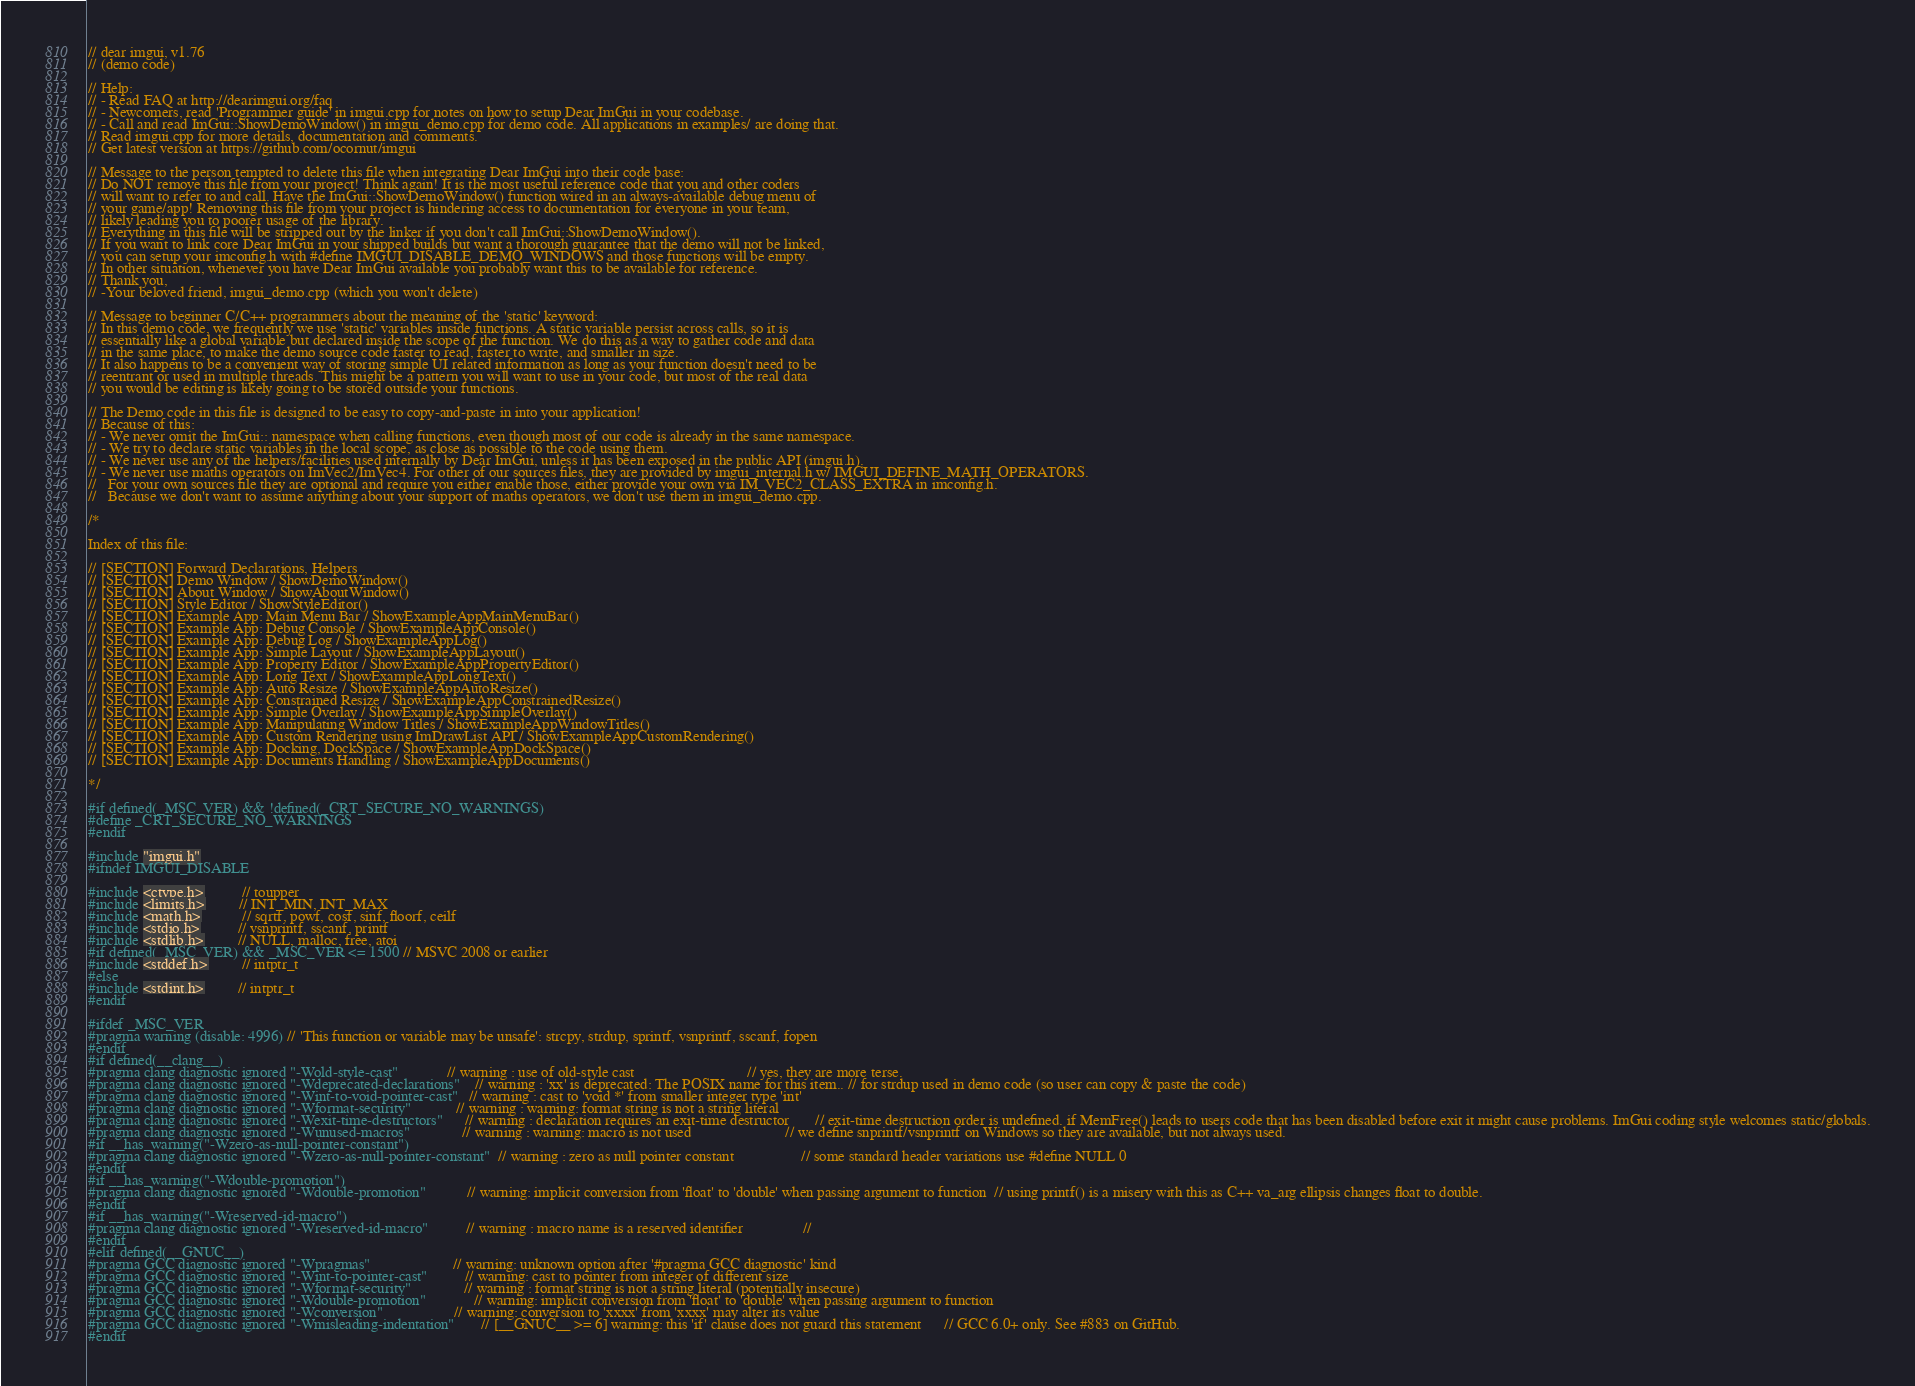<code> <loc_0><loc_0><loc_500><loc_500><_C++_>// dear imgui, v1.76
// (demo code)

// Help:
// - Read FAQ at http://dearimgui.org/faq
// - Newcomers, read 'Programmer guide' in imgui.cpp for notes on how to setup Dear ImGui in your codebase.
// - Call and read ImGui::ShowDemoWindow() in imgui_demo.cpp for demo code. All applications in examples/ are doing that.
// Read imgui.cpp for more details, documentation and comments.
// Get latest version at https://github.com/ocornut/imgui

// Message to the person tempted to delete this file when integrating Dear ImGui into their code base:
// Do NOT remove this file from your project! Think again! It is the most useful reference code that you and other coders
// will want to refer to and call. Have the ImGui::ShowDemoWindow() function wired in an always-available debug menu of
// your game/app! Removing this file from your project is hindering access to documentation for everyone in your team,
// likely leading you to poorer usage of the library.
// Everything in this file will be stripped out by the linker if you don't call ImGui::ShowDemoWindow().
// If you want to link core Dear ImGui in your shipped builds but want a thorough guarantee that the demo will not be linked,
// you can setup your imconfig.h with #define IMGUI_DISABLE_DEMO_WINDOWS and those functions will be empty.
// In other situation, whenever you have Dear ImGui available you probably want this to be available for reference.
// Thank you,
// -Your beloved friend, imgui_demo.cpp (which you won't delete)

// Message to beginner C/C++ programmers about the meaning of the 'static' keyword:
// In this demo code, we frequently we use 'static' variables inside functions. A static variable persist across calls, so it is
// essentially like a global variable but declared inside the scope of the function. We do this as a way to gather code and data
// in the same place, to make the demo source code faster to read, faster to write, and smaller in size.
// It also happens to be a convenient way of storing simple UI related information as long as your function doesn't need to be
// reentrant or used in multiple threads. This might be a pattern you will want to use in your code, but most of the real data
// you would be editing is likely going to be stored outside your functions.

// The Demo code in this file is designed to be easy to copy-and-paste in into your application!
// Because of this:
// - We never omit the ImGui:: namespace when calling functions, even though most of our code is already in the same namespace.
// - We try to declare static variables in the local scope, as close as possible to the code using them.
// - We never use any of the helpers/facilities used internally by Dear ImGui, unless it has been exposed in the public API (imgui.h).
// - We never use maths operators on ImVec2/ImVec4. For other of our sources files, they are provided by imgui_internal.h w/ IMGUI_DEFINE_MATH_OPERATORS.
//   For your own sources file they are optional and require you either enable those, either provide your own via IM_VEC2_CLASS_EXTRA in imconfig.h.
//   Because we don't want to assume anything about your support of maths operators, we don't use them in imgui_demo.cpp.

/*

Index of this file:

// [SECTION] Forward Declarations, Helpers
// [SECTION] Demo Window / ShowDemoWindow()
// [SECTION] About Window / ShowAboutWindow()
// [SECTION] Style Editor / ShowStyleEditor()
// [SECTION] Example App: Main Menu Bar / ShowExampleAppMainMenuBar()
// [SECTION] Example App: Debug Console / ShowExampleAppConsole()
// [SECTION] Example App: Debug Log / ShowExampleAppLog()
// [SECTION] Example App: Simple Layout / ShowExampleAppLayout()
// [SECTION] Example App: Property Editor / ShowExampleAppPropertyEditor()
// [SECTION] Example App: Long Text / ShowExampleAppLongText()
// [SECTION] Example App: Auto Resize / ShowExampleAppAutoResize()
// [SECTION] Example App: Constrained Resize / ShowExampleAppConstrainedResize()
// [SECTION] Example App: Simple Overlay / ShowExampleAppSimpleOverlay()
// [SECTION] Example App: Manipulating Window Titles / ShowExampleAppWindowTitles()
// [SECTION] Example App: Custom Rendering using ImDrawList API / ShowExampleAppCustomRendering()
// [SECTION] Example App: Docking, DockSpace / ShowExampleAppDockSpace()
// [SECTION] Example App: Documents Handling / ShowExampleAppDocuments()

*/

#if defined(_MSC_VER) && !defined(_CRT_SECURE_NO_WARNINGS)
#define _CRT_SECURE_NO_WARNINGS
#endif

#include "imgui.h"
#ifndef IMGUI_DISABLE

#include <ctype.h>          // toupper
#include <limits.h>         // INT_MIN, INT_MAX
#include <math.h>           // sqrtf, powf, cosf, sinf, floorf, ceilf
#include <stdio.h>          // vsnprintf, sscanf, printf
#include <stdlib.h>         // NULL, malloc, free, atoi
#if defined(_MSC_VER) && _MSC_VER <= 1500 // MSVC 2008 or earlier
#include <stddef.h>         // intptr_t
#else
#include <stdint.h>         // intptr_t
#endif

#ifdef _MSC_VER
#pragma warning (disable: 4996) // 'This function or variable may be unsafe': strcpy, strdup, sprintf, vsnprintf, sscanf, fopen
#endif
#if defined(__clang__)
#pragma clang diagnostic ignored "-Wold-style-cast"             // warning : use of old-style cast                              // yes, they are more terse.
#pragma clang diagnostic ignored "-Wdeprecated-declarations"    // warning : 'xx' is deprecated: The POSIX name for this item.. // for strdup used in demo code (so user can copy & paste the code)
#pragma clang diagnostic ignored "-Wint-to-void-pointer-cast"   // warning : cast to 'void *' from smaller integer type 'int'
#pragma clang diagnostic ignored "-Wformat-security"            // warning : warning: format string is not a string literal
#pragma clang diagnostic ignored "-Wexit-time-destructors"      // warning : declaration requires an exit-time destructor       // exit-time destruction order is undefined. if MemFree() leads to users code that has been disabled before exit it might cause problems. ImGui coding style welcomes static/globals.
#pragma clang diagnostic ignored "-Wunused-macros"              // warning : warning: macro is not used                         // we define snprintf/vsnprintf on Windows so they are available, but not always used.
#if __has_warning("-Wzero-as-null-pointer-constant")
#pragma clang diagnostic ignored "-Wzero-as-null-pointer-constant"  // warning : zero as null pointer constant                  // some standard header variations use #define NULL 0
#endif
#if __has_warning("-Wdouble-promotion")
#pragma clang diagnostic ignored "-Wdouble-promotion"           // warning: implicit conversion from 'float' to 'double' when passing argument to function  // using printf() is a misery with this as C++ va_arg ellipsis changes float to double.
#endif
#if __has_warning("-Wreserved-id-macro")
#pragma clang diagnostic ignored "-Wreserved-id-macro"          // warning : macro name is a reserved identifier                //
#endif
#elif defined(__GNUC__)
#pragma GCC diagnostic ignored "-Wpragmas"                      // warning: unknown option after '#pragma GCC diagnostic' kind
#pragma GCC diagnostic ignored "-Wint-to-pointer-cast"          // warning: cast to pointer from integer of different size
#pragma GCC diagnostic ignored "-Wformat-security"              // warning : format string is not a string literal (potentially insecure)
#pragma GCC diagnostic ignored "-Wdouble-promotion"             // warning: implicit conversion from 'float' to 'double' when passing argument to function
#pragma GCC diagnostic ignored "-Wconversion"                   // warning: conversion to 'xxxx' from 'xxxx' may alter its value
#pragma GCC diagnostic ignored "-Wmisleading-indentation"       // [__GNUC__ >= 6] warning: this 'if' clause does not guard this statement      // GCC 6.0+ only. See #883 on GitHub.
#endif
</code> 